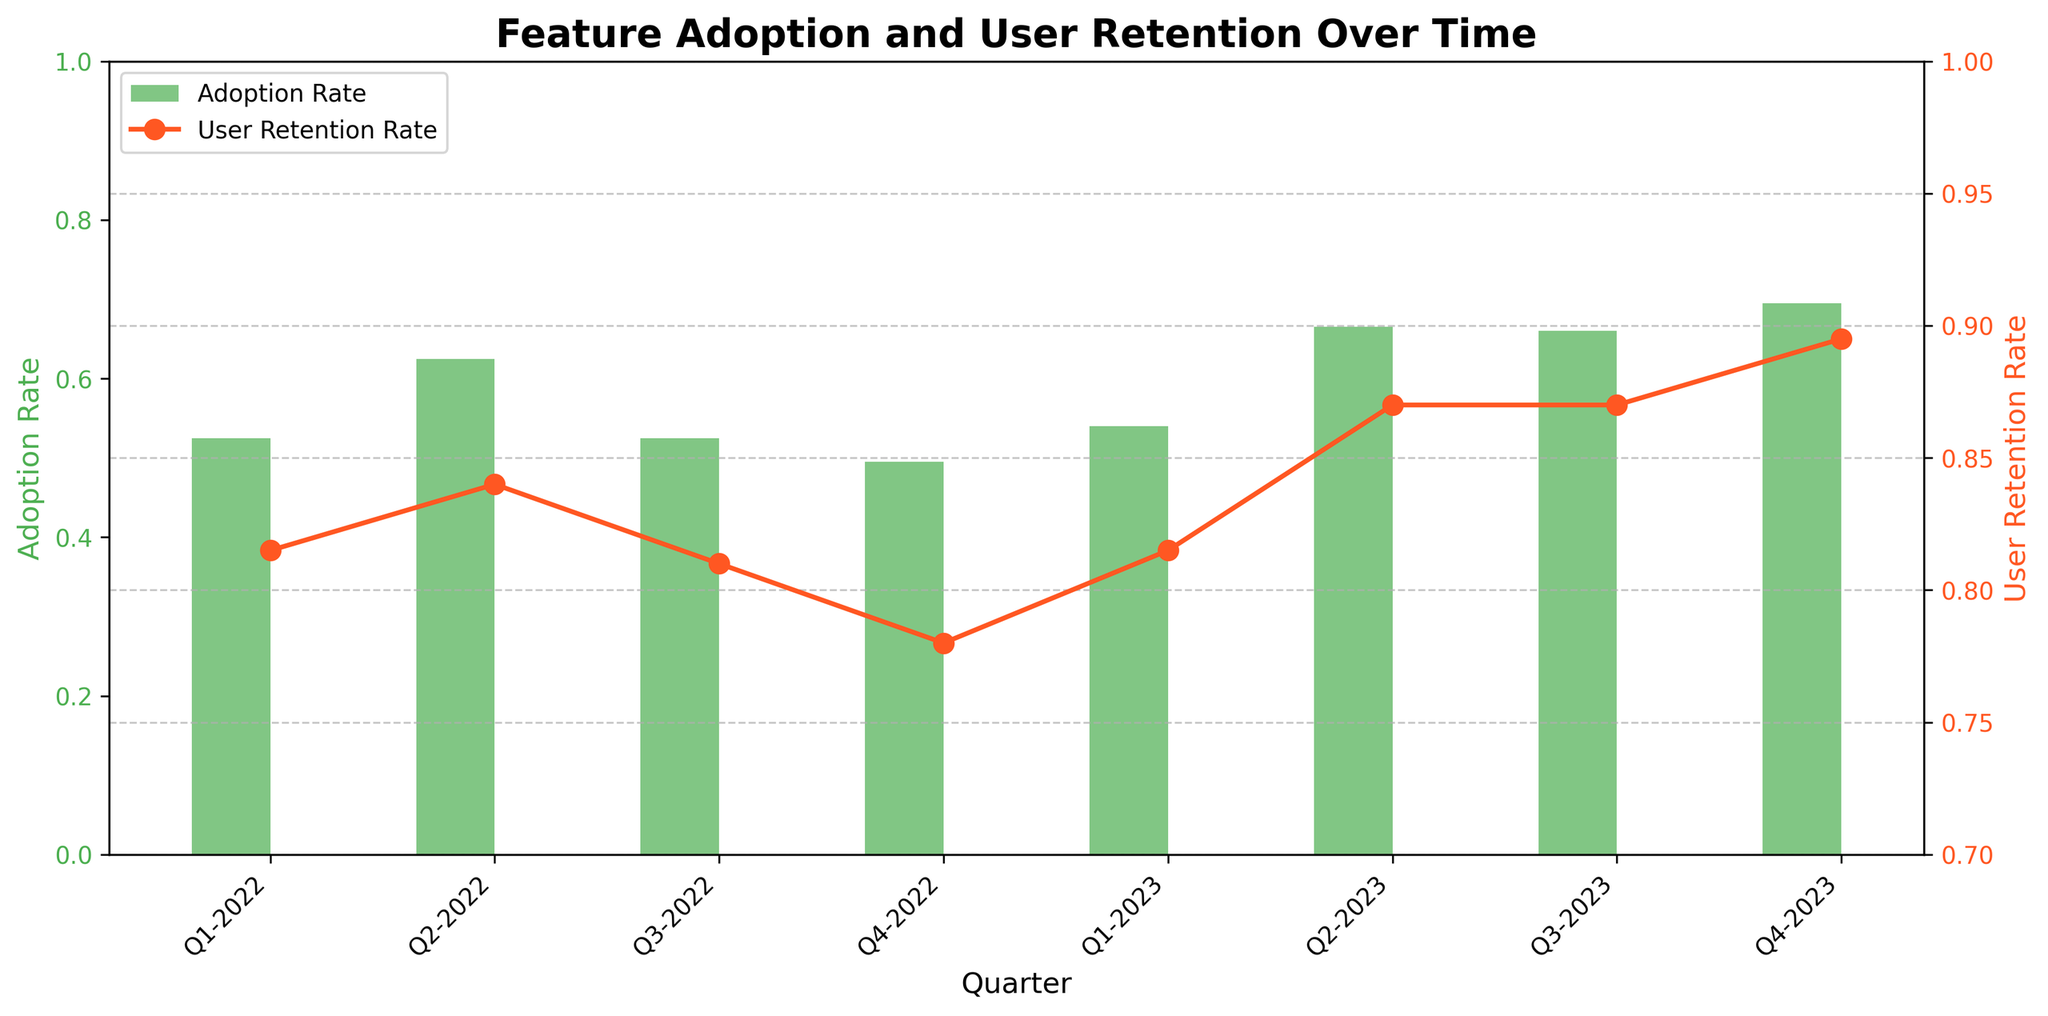What's the title of the plot? The title of the plot is displayed at the top of the figure. We can read the text directly from there.
Answer: Feature Adoption and User Retention Over Time Which quarter has the highest Adoption Rate? We can see the adoption rates for each quarter by examining the heights of the green bars and identifying the highest one.
Answer: Q4-2023 Which quarter has the highest User Retention Rate? By looking at the highest point on the orange line, we can identify the quarter with the highest Retention Rate.
Answer: Q4-2023 How does the Adoption Rate trend from Q1-2022 to Q4-2023? Observing the green bars from left to right, we can note the general increase or decrease in their heights.
Answer: Generally increasing What is the average Adoption Rate in 2022? We need to add the adoption rates of all quarters in 2022 and divide by the number of quarters. (0.65 + 0.40 + 0.55 + 0.50 + 0.60 + 0.48 + 0.70 + 0.62) / 4 = 2.51 / 4
Answer: 0.6275 How does the User Retention Rate in Q4-2023 compare to Q1-2023? We compare the heights of the orange markers for Q4-2023 and Q1-2023.
Answer: Higher in Q4-2023 Which feature had the lowest Adoption Rate and in which quarter? We can cross-reference the individual green bars with the given data table to find the lowest adoption rate and the corresponding feature and quarter.
Answer: MobileWidget in Q2-2023 Is there a visible correlation between Adoption Rate and User Retention Rate? By examining the trends of the green bars and the orange line, we can determine if they move in parallel or oppositely.
Answer: Yes, generally positive What is the Adoption Rate in Q3-2023? We look at the height of the green bar for Q3-2023 in the plot.
Answer: 0.72 Is there any quarter where the Adoption Rate and User Retention Rate trends show significant divergence? By comparing the bars and line markers horizontally for each quarter, we can identify any quarter with a large discrepancy between the two metrics.
Answer: Q2-2022 (larger difference) 